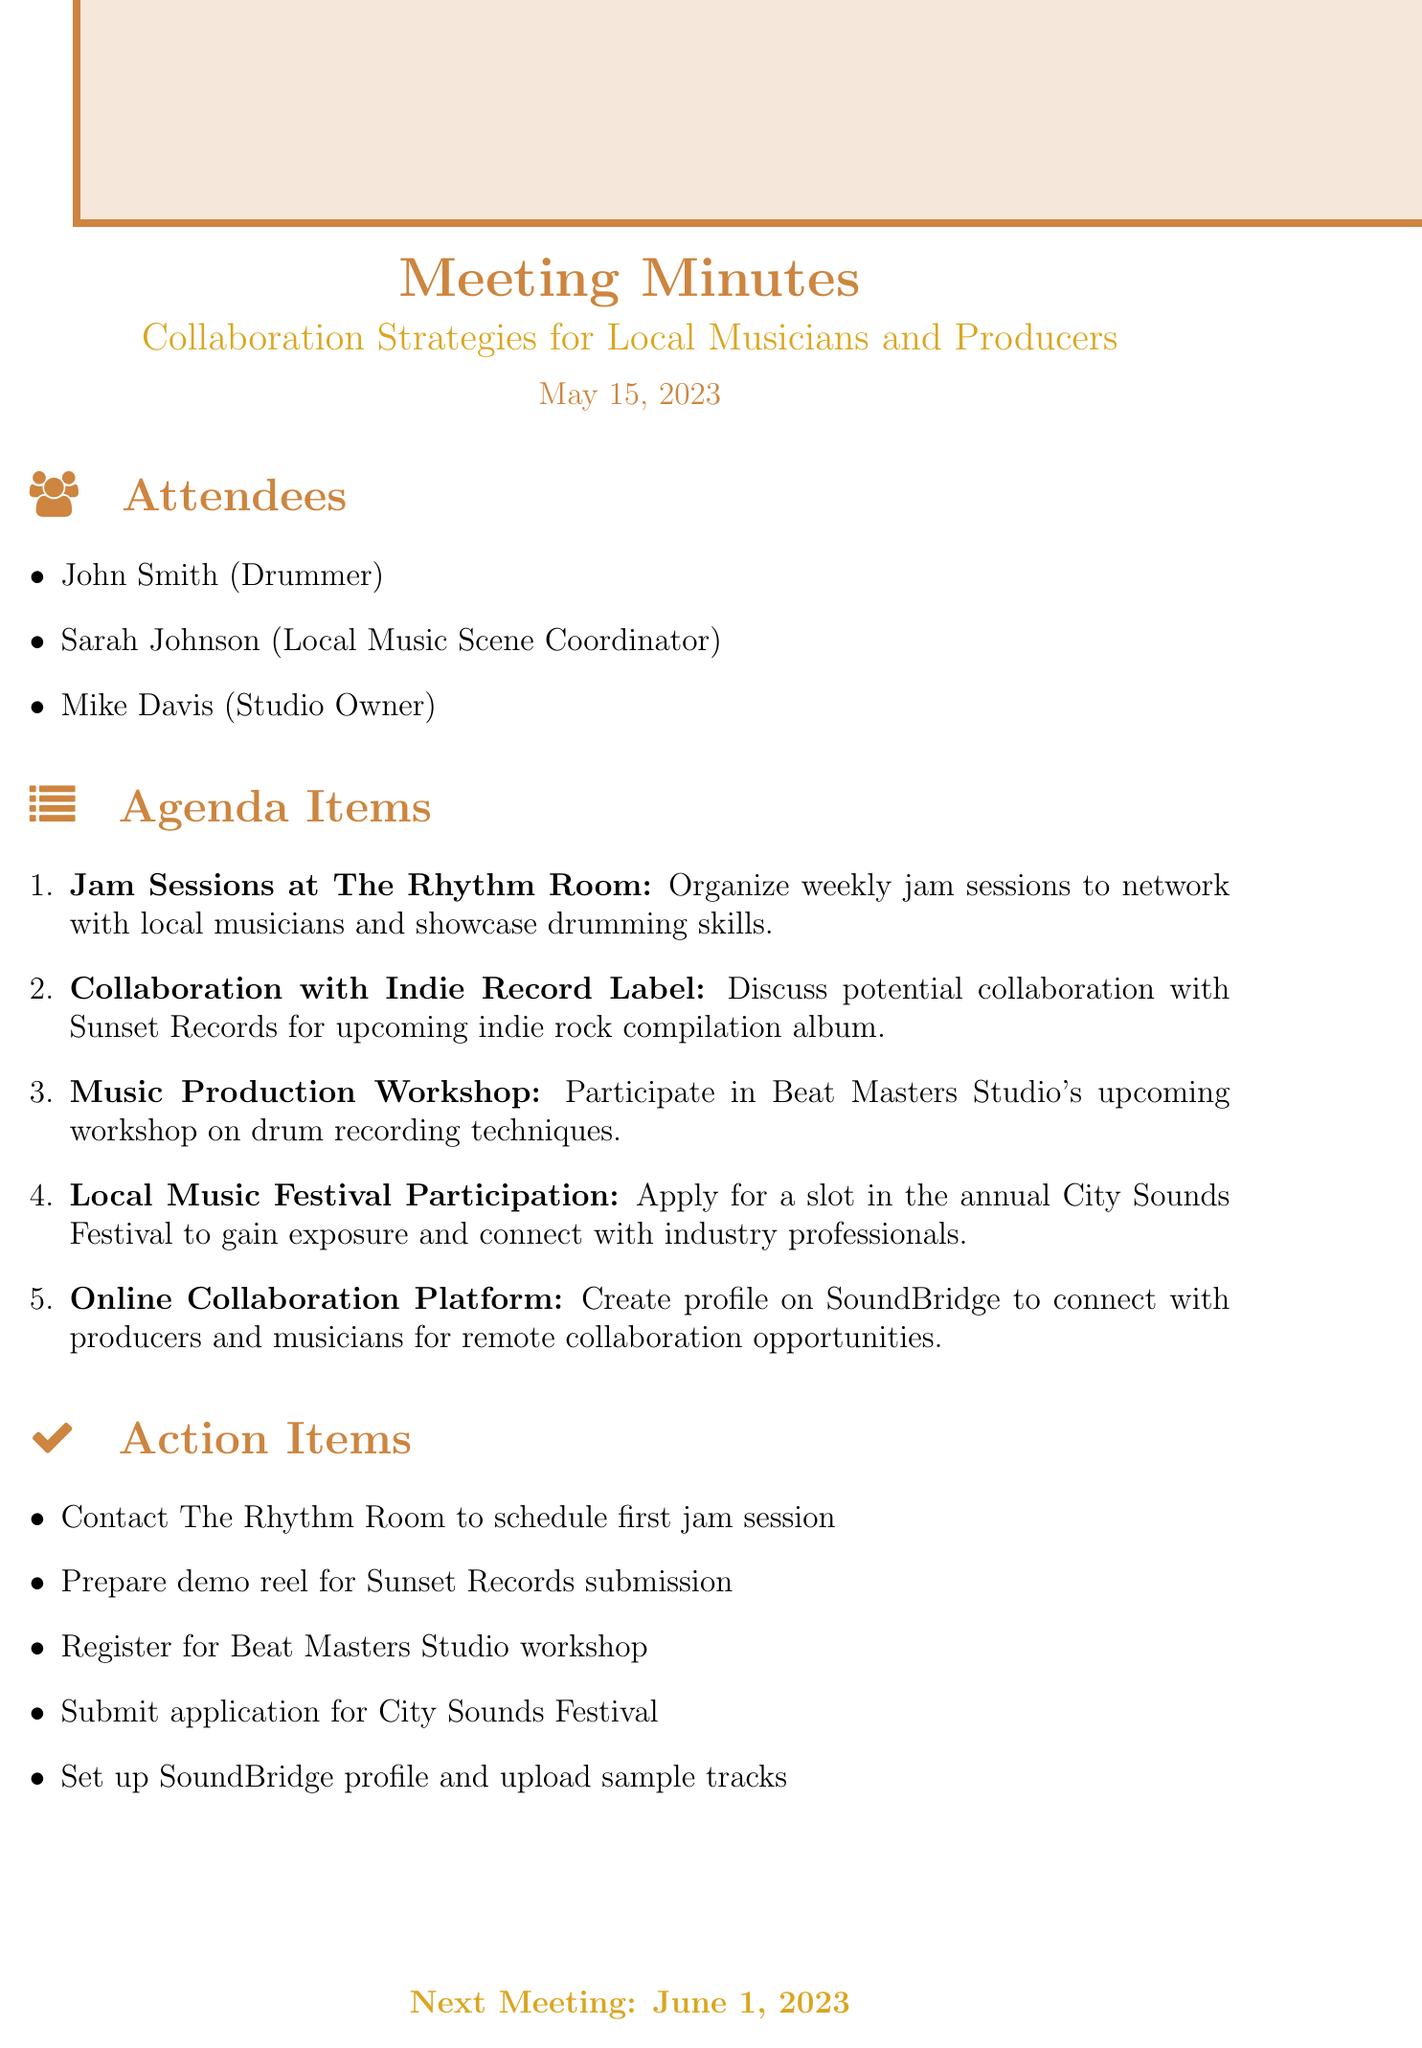What is the meeting title? The meeting title is stated at the beginning of the document and refers to the focus of the discussions held.
Answer: Collaboration Strategies for Local Musicians and Producers Who are the attendees? The attendees list provides the names and roles of the people involved in the meeting.
Answer: John Smith, Sarah Johnson, Mike Davis What is the date of the meeting? The date indicates when the meeting took place, which is important for keeping records.
Answer: May 15, 2023 What is one of the agenda items discussed? The agenda items outline the specific topics that were planned for discussion during the meeting.
Answer: Jam Sessions at The Rhythm Room How many action items are listed? The action items list the tasks that need to be followed up after the meeting; the count reflects the number of tasks agreed upon.
Answer: Five What is the purpose of the jam sessions? The purpose is stated clearly in the details of the agenda item, highlighting the goal of the proposed activity.
Answer: To network with local musicians and showcase drumming skills When is the next meeting scheduled? The date for the next meeting is mentioned in the document, indicating continuity in discussions.
Answer: June 1, 2023 What workshop are attendees encouraged to register for? The specific workshop is included in the agenda items, emphasizing its relevance to skill development.
Answer: Beat Masters Studio workshop What platform is suggested for online collaboration? The specific online platform mentioned for connecting musicians and producers is a key detail for digital networking.
Answer: SoundBridge 